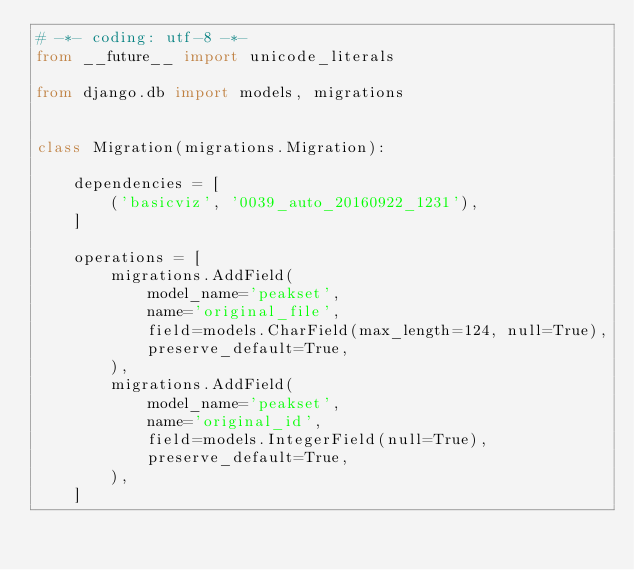Convert code to text. <code><loc_0><loc_0><loc_500><loc_500><_Python_># -*- coding: utf-8 -*-
from __future__ import unicode_literals

from django.db import models, migrations


class Migration(migrations.Migration):

    dependencies = [
        ('basicviz', '0039_auto_20160922_1231'),
    ]

    operations = [
        migrations.AddField(
            model_name='peakset',
            name='original_file',
            field=models.CharField(max_length=124, null=True),
            preserve_default=True,
        ),
        migrations.AddField(
            model_name='peakset',
            name='original_id',
            field=models.IntegerField(null=True),
            preserve_default=True,
        ),
    ]
</code> 